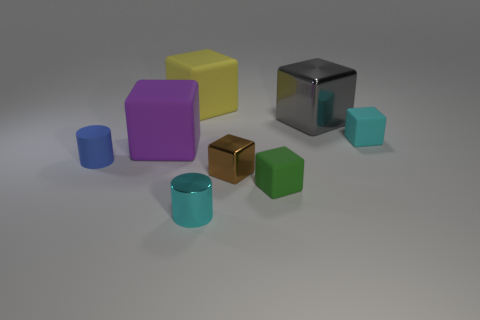Subtract all yellow matte blocks. How many blocks are left? 5 Subtract all gray cubes. How many cubes are left? 5 Subtract all purple blocks. Subtract all purple cylinders. How many blocks are left? 5 Add 1 tiny red metallic cylinders. How many objects exist? 9 Subtract all blocks. How many objects are left? 2 Add 3 big red metal cylinders. How many big red metal cylinders exist? 3 Subtract 0 brown spheres. How many objects are left? 8 Subtract all large cyan cubes. Subtract all tiny cyan shiny cylinders. How many objects are left? 7 Add 6 purple cubes. How many purple cubes are left? 7 